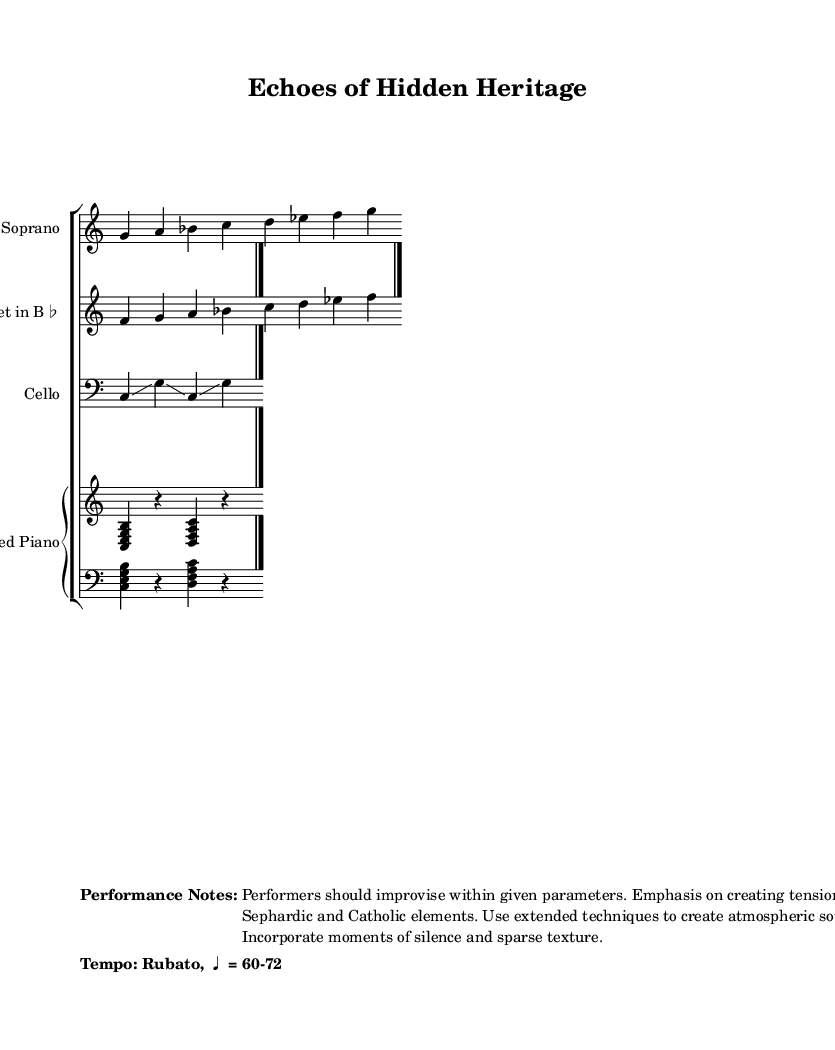What is the time signature of this music? The time signature appears as 4/4 at the beginning of the soprano voice part, indicating four beats per measure.
Answer: 4/4 What is the indicated tempo of the piece? The tempo is noted as "Rubato, ♩ = 60-72" at the bottom of the score, suggesting a flexible speed that can vary between those beats per minute.
Answer: Rubato, ♩ = 60-72 What type of instrument is the clarinet in this score? The instrument is labeled as "Clarinet in B♭," which indicates that it is a B♭ transposing instrument, sounding a whole step lower than written.
Answer: Clarinet in B♭ Identify one extended technique suggested for the performers. The performance notes mention "extended techniques" that enhance the atmospheric quality, leading to sounds beyond standard playing. An example technique is glissando, as indicated in the cello part.
Answer: Glissando What is the structural role of the prepared piano in this composition? The prepared piano part is written to create unique textures and sounds by suggesting silence and interruptions, meant to contrast with the vocal and instrumental lines.
Answer: Unique textures Describe the intended musical interaction between the Sephardic and Catholic elements. The instructions in the performance notes emphasize creating tension between the Sephardic elements, represented by the melodies, and the Catholic components, hinting at a dialogic relationship throughout the music.
Answer: Create tension 